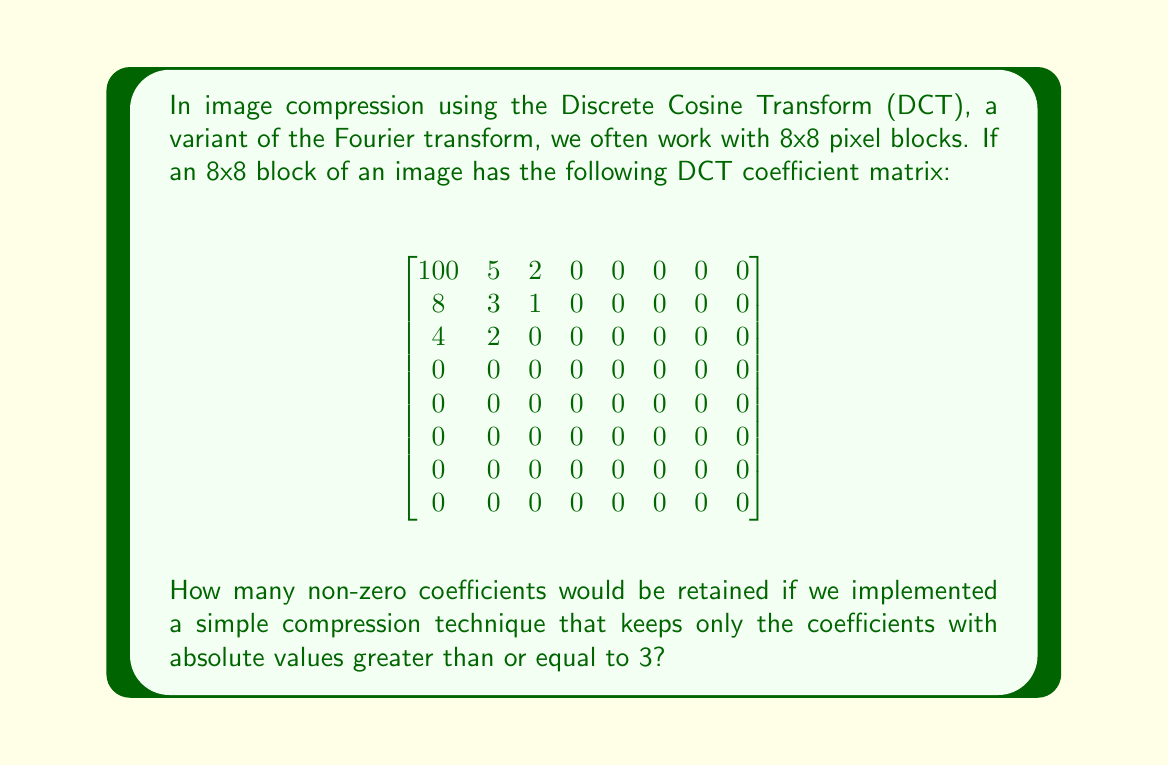Help me with this question. To solve this problem, we need to count the number of coefficients in the DCT matrix that have an absolute value greater than or equal to 3. Let's go through this step-by-step:

1. First, let's identify all the coefficients that meet our criteria:

   $|100| \geq 3$
   $|5| \geq 3$
   $|8| \geq 3$
   $|3| \geq 3$
   $|4| \geq 3$

2. Now, let's count these coefficients:
   - In the first row: 2 coefficients (100 and 5)
   - In the second row: 2 coefficients (8 and 3)
   - In the third row: 1 coefficient (4)
   - All other rows have no coefficients meeting the criteria

3. Adding these up: 2 + 2 + 1 = 5

This compression technique is similar to how JPEG compression works, where less significant coefficients (usually higher frequency components) are discarded to reduce file size at the cost of some image quality.

In a TypeScript implementation, you might represent this DCT coefficient matrix as a 2D array and use a simple loop with a condition to count or retain these significant coefficients.
Answer: 5 coefficients 